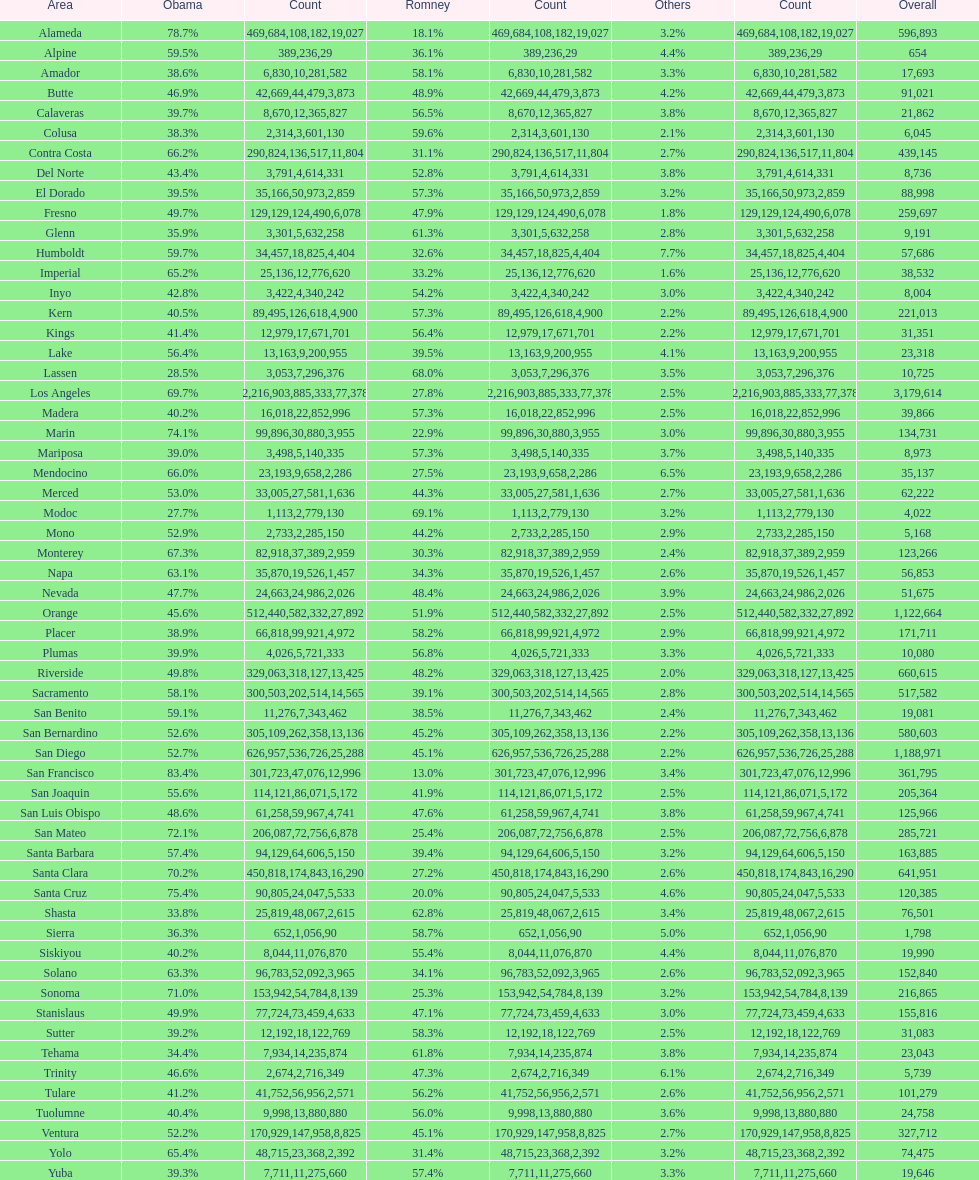Which county had the most total votes? Los Angeles. Can you give me this table as a dict? {'header': ['Area', 'Obama', 'Count', 'Romney', 'Count', 'Others', 'Count', 'Overall'], 'rows': [['Alameda', '78.7%', '469,684', '18.1%', '108,182', '3.2%', '19,027', '596,893'], ['Alpine', '59.5%', '389', '36.1%', '236', '4.4%', '29', '654'], ['Amador', '38.6%', '6,830', '58.1%', '10,281', '3.3%', '582', '17,693'], ['Butte', '46.9%', '42,669', '48.9%', '44,479', '4.2%', '3,873', '91,021'], ['Calaveras', '39.7%', '8,670', '56.5%', '12,365', '3.8%', '827', '21,862'], ['Colusa', '38.3%', '2,314', '59.6%', '3,601', '2.1%', '130', '6,045'], ['Contra Costa', '66.2%', '290,824', '31.1%', '136,517', '2.7%', '11,804', '439,145'], ['Del Norte', '43.4%', '3,791', '52.8%', '4,614', '3.8%', '331', '8,736'], ['El Dorado', '39.5%', '35,166', '57.3%', '50,973', '3.2%', '2,859', '88,998'], ['Fresno', '49.7%', '129,129', '47.9%', '124,490', '1.8%', '6,078', '259,697'], ['Glenn', '35.9%', '3,301', '61.3%', '5,632', '2.8%', '258', '9,191'], ['Humboldt', '59.7%', '34,457', '32.6%', '18,825', '7.7%', '4,404', '57,686'], ['Imperial', '65.2%', '25,136', '33.2%', '12,776', '1.6%', '620', '38,532'], ['Inyo', '42.8%', '3,422', '54.2%', '4,340', '3.0%', '242', '8,004'], ['Kern', '40.5%', '89,495', '57.3%', '126,618', '2.2%', '4,900', '221,013'], ['Kings', '41.4%', '12,979', '56.4%', '17,671', '2.2%', '701', '31,351'], ['Lake', '56.4%', '13,163', '39.5%', '9,200', '4.1%', '955', '23,318'], ['Lassen', '28.5%', '3,053', '68.0%', '7,296', '3.5%', '376', '10,725'], ['Los Angeles', '69.7%', '2,216,903', '27.8%', '885,333', '2.5%', '77,378', '3,179,614'], ['Madera', '40.2%', '16,018', '57.3%', '22,852', '2.5%', '996', '39,866'], ['Marin', '74.1%', '99,896', '22.9%', '30,880', '3.0%', '3,955', '134,731'], ['Mariposa', '39.0%', '3,498', '57.3%', '5,140', '3.7%', '335', '8,973'], ['Mendocino', '66.0%', '23,193', '27.5%', '9,658', '6.5%', '2,286', '35,137'], ['Merced', '53.0%', '33,005', '44.3%', '27,581', '2.7%', '1,636', '62,222'], ['Modoc', '27.7%', '1,113', '69.1%', '2,779', '3.2%', '130', '4,022'], ['Mono', '52.9%', '2,733', '44.2%', '2,285', '2.9%', '150', '5,168'], ['Monterey', '67.3%', '82,918', '30.3%', '37,389', '2.4%', '2,959', '123,266'], ['Napa', '63.1%', '35,870', '34.3%', '19,526', '2.6%', '1,457', '56,853'], ['Nevada', '47.7%', '24,663', '48.4%', '24,986', '3.9%', '2,026', '51,675'], ['Orange', '45.6%', '512,440', '51.9%', '582,332', '2.5%', '27,892', '1,122,664'], ['Placer', '38.9%', '66,818', '58.2%', '99,921', '2.9%', '4,972', '171,711'], ['Plumas', '39.9%', '4,026', '56.8%', '5,721', '3.3%', '333', '10,080'], ['Riverside', '49.8%', '329,063', '48.2%', '318,127', '2.0%', '13,425', '660,615'], ['Sacramento', '58.1%', '300,503', '39.1%', '202,514', '2.8%', '14,565', '517,582'], ['San Benito', '59.1%', '11,276', '38.5%', '7,343', '2.4%', '462', '19,081'], ['San Bernardino', '52.6%', '305,109', '45.2%', '262,358', '2.2%', '13,136', '580,603'], ['San Diego', '52.7%', '626,957', '45.1%', '536,726', '2.2%', '25,288', '1,188,971'], ['San Francisco', '83.4%', '301,723', '13.0%', '47,076', '3.4%', '12,996', '361,795'], ['San Joaquin', '55.6%', '114,121', '41.9%', '86,071', '2.5%', '5,172', '205,364'], ['San Luis Obispo', '48.6%', '61,258', '47.6%', '59,967', '3.8%', '4,741', '125,966'], ['San Mateo', '72.1%', '206,087', '25.4%', '72,756', '2.5%', '6,878', '285,721'], ['Santa Barbara', '57.4%', '94,129', '39.4%', '64,606', '3.2%', '5,150', '163,885'], ['Santa Clara', '70.2%', '450,818', '27.2%', '174,843', '2.6%', '16,290', '641,951'], ['Santa Cruz', '75.4%', '90,805', '20.0%', '24,047', '4.6%', '5,533', '120,385'], ['Shasta', '33.8%', '25,819', '62.8%', '48,067', '3.4%', '2,615', '76,501'], ['Sierra', '36.3%', '652', '58.7%', '1,056', '5.0%', '90', '1,798'], ['Siskiyou', '40.2%', '8,044', '55.4%', '11,076', '4.4%', '870', '19,990'], ['Solano', '63.3%', '96,783', '34.1%', '52,092', '2.6%', '3,965', '152,840'], ['Sonoma', '71.0%', '153,942', '25.3%', '54,784', '3.2%', '8,139', '216,865'], ['Stanislaus', '49.9%', '77,724', '47.1%', '73,459', '3.0%', '4,633', '155,816'], ['Sutter', '39.2%', '12,192', '58.3%', '18,122', '2.5%', '769', '31,083'], ['Tehama', '34.4%', '7,934', '61.8%', '14,235', '3.8%', '874', '23,043'], ['Trinity', '46.6%', '2,674', '47.3%', '2,716', '6.1%', '349', '5,739'], ['Tulare', '41.2%', '41,752', '56.2%', '56,956', '2.6%', '2,571', '101,279'], ['Tuolumne', '40.4%', '9,998', '56.0%', '13,880', '3.6%', '880', '24,758'], ['Ventura', '52.2%', '170,929', '45.1%', '147,958', '2.7%', '8,825', '327,712'], ['Yolo', '65.4%', '48,715', '31.4%', '23,368', '3.2%', '2,392', '74,475'], ['Yuba', '39.3%', '7,711', '57.4%', '11,275', '3.3%', '660', '19,646']]} 